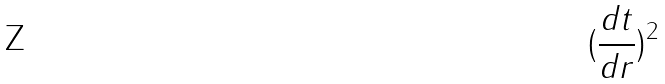Convert formula to latex. <formula><loc_0><loc_0><loc_500><loc_500>( \frac { d t } { d r } ) ^ { 2 }</formula> 